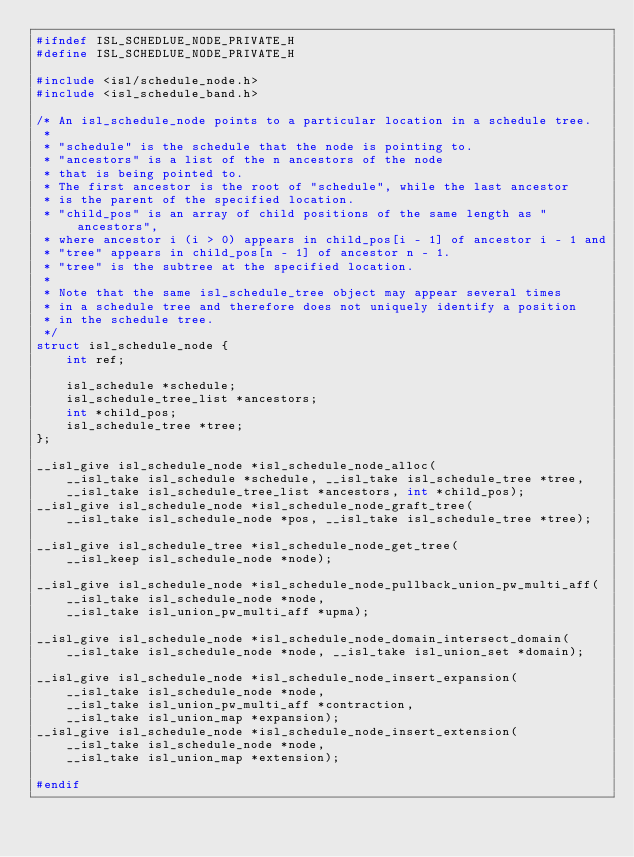Convert code to text. <code><loc_0><loc_0><loc_500><loc_500><_C_>#ifndef ISL_SCHEDLUE_NODE_PRIVATE_H
#define ISL_SCHEDLUE_NODE_PRIVATE_H

#include <isl/schedule_node.h>
#include <isl_schedule_band.h>

/* An isl_schedule_node points to a particular location in a schedule tree.
 *
 * "schedule" is the schedule that the node is pointing to.
 * "ancestors" is a list of the n ancestors of the node
 * that is being pointed to.
 * The first ancestor is the root of "schedule", while the last ancestor
 * is the parent of the specified location.
 * "child_pos" is an array of child positions of the same length as "ancestors",
 * where ancestor i (i > 0) appears in child_pos[i - 1] of ancestor i - 1 and
 * "tree" appears in child_pos[n - 1] of ancestor n - 1.
 * "tree" is the subtree at the specified location.
 *
 * Note that the same isl_schedule_tree object may appear several times
 * in a schedule tree and therefore does not uniquely identify a position
 * in the schedule tree.
 */
struct isl_schedule_node {
	int ref;

	isl_schedule *schedule;
	isl_schedule_tree_list *ancestors;
	int *child_pos;
	isl_schedule_tree *tree;
};

__isl_give isl_schedule_node *isl_schedule_node_alloc(
	__isl_take isl_schedule *schedule, __isl_take isl_schedule_tree *tree,
	__isl_take isl_schedule_tree_list *ancestors, int *child_pos);
__isl_give isl_schedule_node *isl_schedule_node_graft_tree(
	__isl_take isl_schedule_node *pos, __isl_take isl_schedule_tree *tree);

__isl_give isl_schedule_tree *isl_schedule_node_get_tree(
	__isl_keep isl_schedule_node *node);

__isl_give isl_schedule_node *isl_schedule_node_pullback_union_pw_multi_aff(
	__isl_take isl_schedule_node *node,
	__isl_take isl_union_pw_multi_aff *upma);

__isl_give isl_schedule_node *isl_schedule_node_domain_intersect_domain(
	__isl_take isl_schedule_node *node, __isl_take isl_union_set *domain);

__isl_give isl_schedule_node *isl_schedule_node_insert_expansion(
	__isl_take isl_schedule_node *node,
	__isl_take isl_union_pw_multi_aff *contraction,
	__isl_take isl_union_map *expansion);
__isl_give isl_schedule_node *isl_schedule_node_insert_extension(
	__isl_take isl_schedule_node *node,
	__isl_take isl_union_map *extension);

#endif
</code> 